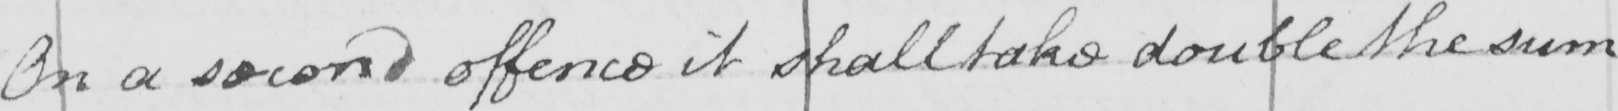Please transcribe the handwritten text in this image. On a second offence it shall take double the sum 